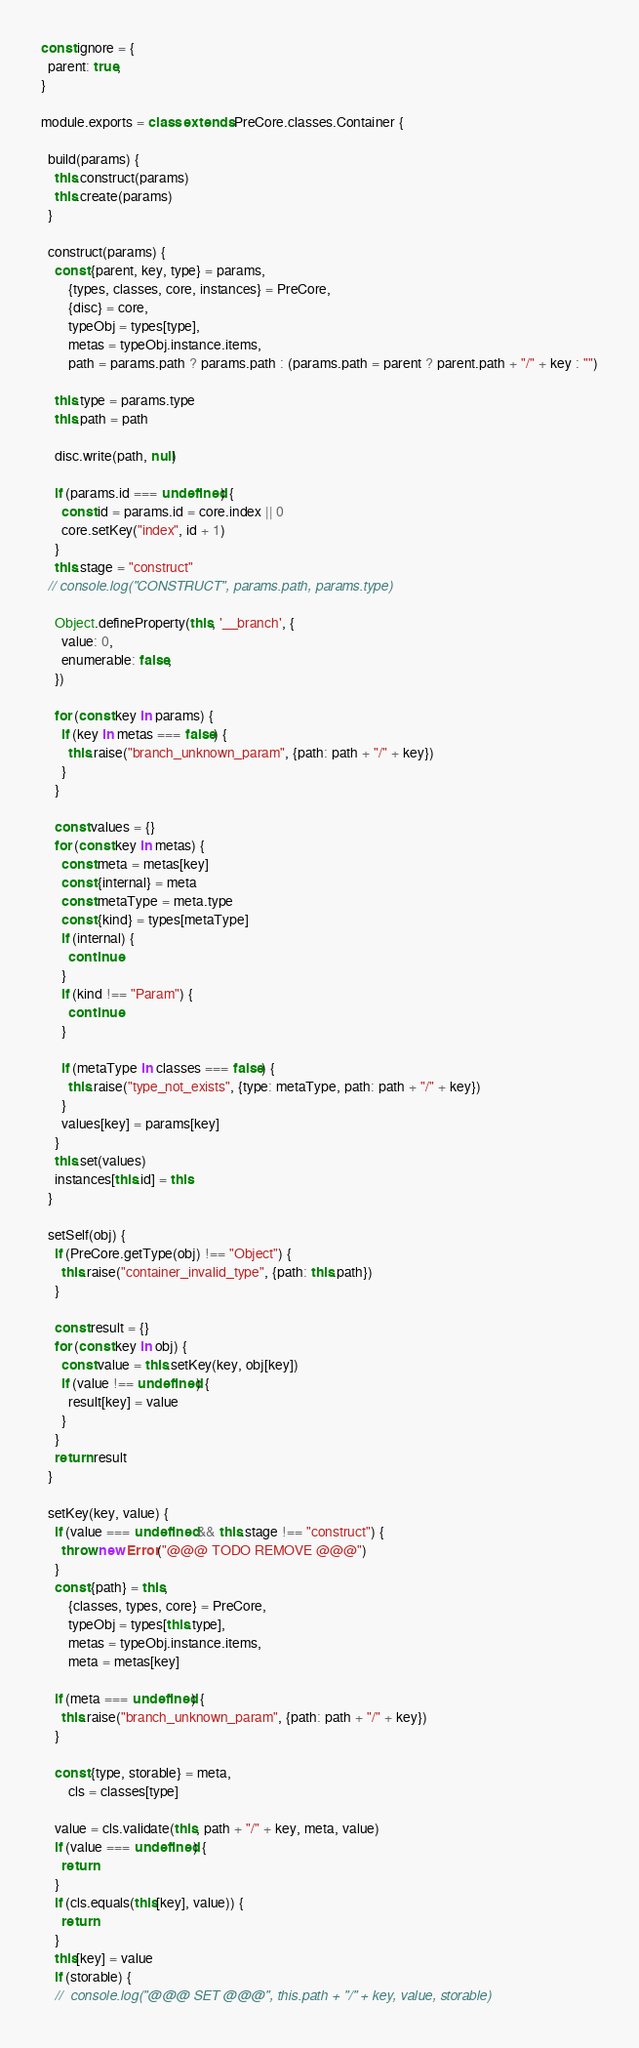Convert code to text. <code><loc_0><loc_0><loc_500><loc_500><_JavaScript_>const ignore = {
  parent: true,
}

module.exports = class extends PreCore.classes.Container {

  build(params) {
    this.construct(params)
    this.create(params)
  }

  construct(params) {
    const {parent, key, type} = params,
        {types, classes, core, instances} = PreCore,
        {disc} = core,
        typeObj = types[type],
        metas = typeObj.instance.items,
        path = params.path ? params.path : (params.path = parent ? parent.path + "/" + key : "")

    this.type = params.type
    this.path = path

    disc.write(path, null)

    if (params.id === undefined) {
      const id = params.id = core.index || 0
      core.setKey("index", id + 1)
    }
    this.stage = "construct"
  // console.log("CONSTRUCT", params.path, params.type)

    Object.defineProperty(this, '__branch', {
      value: 0,
      enumerable: false,
    })

    for (const key in params) {
      if (key in metas === false) {
        this.raise("branch_unknown_param", {path: path + "/" + key})
      }
    }

    const values = {}
    for (const key in metas) {
      const meta = metas[key]
      const {internal} = meta
      const metaType = meta.type
      const {kind} = types[metaType]
      if (internal) {
        continue
      }
      if (kind !== "Param") {
        continue
      }

      if (metaType in classes === false) {
        this.raise("type_not_exists", {type: metaType, path: path + "/" + key})
      }
      values[key] = params[key]
    }
    this.set(values)
    instances[this.id] = this
  }

  setSelf(obj) {
    if (PreCore.getType(obj) !== "Object") {
      this.raise("container_invalid_type", {path: this.path})
    }

    const result = {}
    for (const key in obj) {
      const value = this.setKey(key, obj[key])
      if (value !== undefined) {
        result[key] = value
      }
    }
    return result
  }

  setKey(key, value) {
    if (value === undefined && this.stage !== "construct") {
      throw new Error("@@@ TODO REMOVE @@@")
    }
    const {path} = this,
        {classes, types, core} = PreCore,
        typeObj = types[this.type],
        metas = typeObj.instance.items,
        meta = metas[key]

    if (meta === undefined) {
      this.raise("branch_unknown_param", {path: path + "/" + key})
    }

    const {type, storable} = meta,
        cls = classes[type]

    value = cls.validate(this, path + "/" + key, meta, value)
    if (value === undefined) {
      return
    }
    if (cls.equals(this[key], value)) {
      return
    }
    this[key] = value
    if (storable) {
    //  console.log("@@@ SET @@@", this.path + "/" + key, value, storable)</code> 